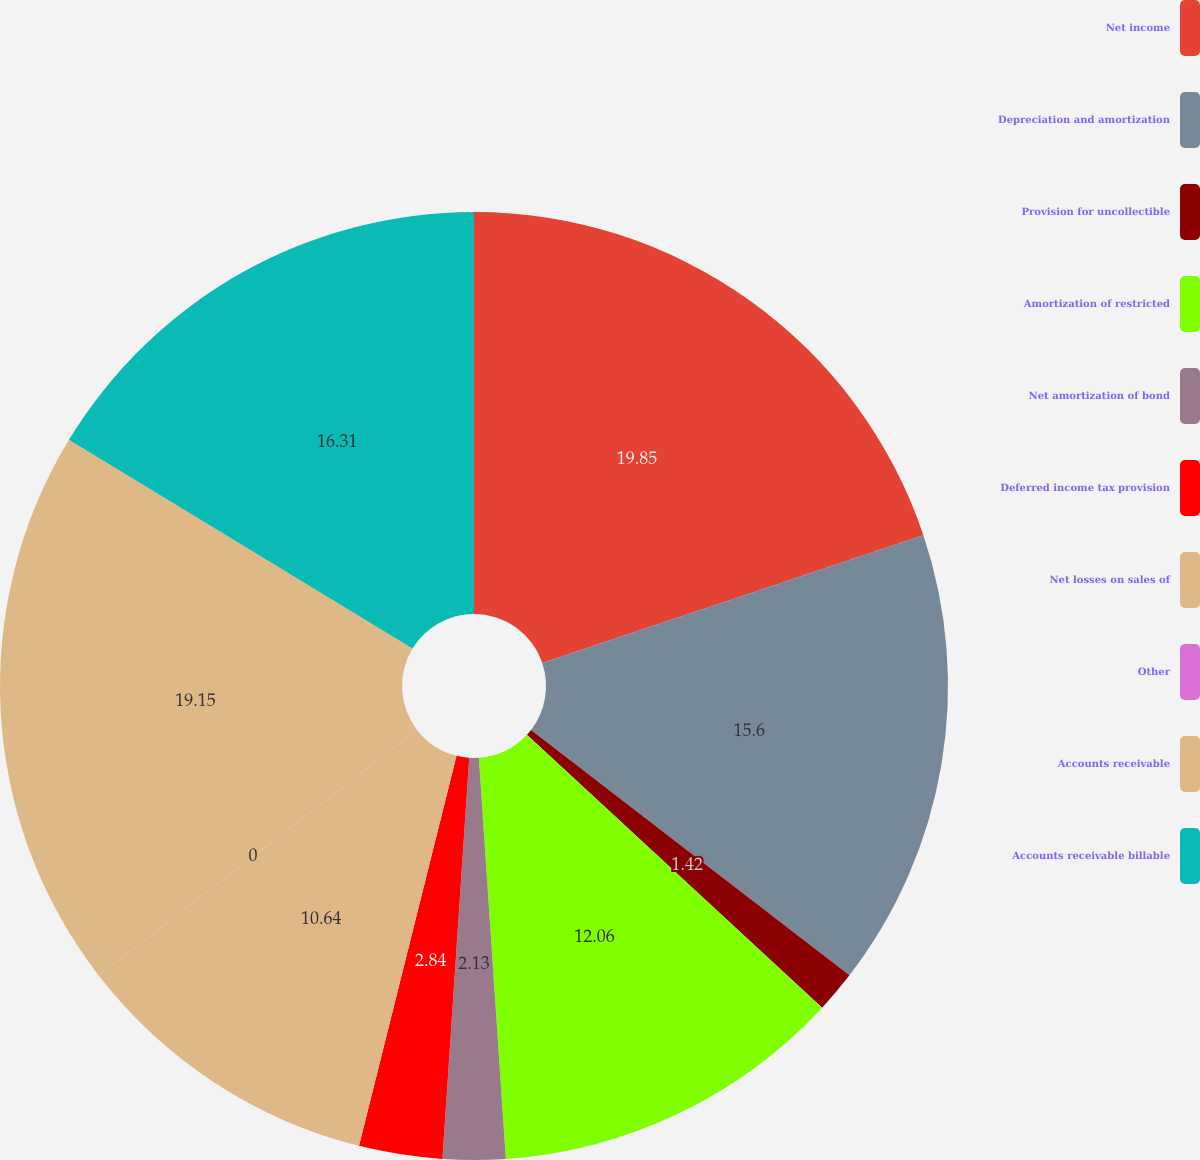Convert chart to OTSL. <chart><loc_0><loc_0><loc_500><loc_500><pie_chart><fcel>Net income<fcel>Depreciation and amortization<fcel>Provision for uncollectible<fcel>Amortization of restricted<fcel>Net amortization of bond<fcel>Deferred income tax provision<fcel>Net losses on sales of<fcel>Other<fcel>Accounts receivable<fcel>Accounts receivable billable<nl><fcel>19.85%<fcel>15.6%<fcel>1.42%<fcel>12.06%<fcel>2.13%<fcel>2.84%<fcel>10.64%<fcel>0.0%<fcel>19.15%<fcel>16.31%<nl></chart> 